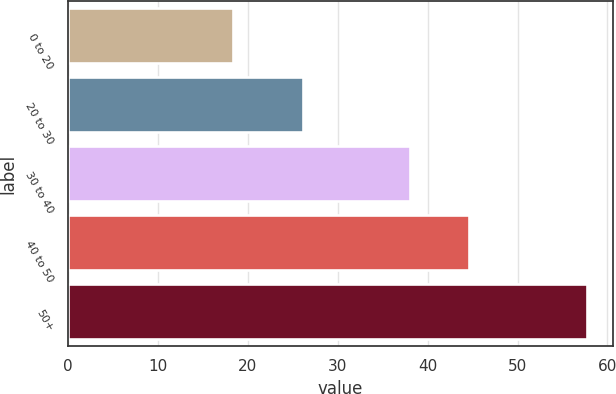Convert chart. <chart><loc_0><loc_0><loc_500><loc_500><bar_chart><fcel>0 to 20<fcel>20 to 30<fcel>30 to 40<fcel>40 to 50<fcel>50+<nl><fcel>18.37<fcel>26.15<fcel>38.05<fcel>44.59<fcel>57.71<nl></chart> 